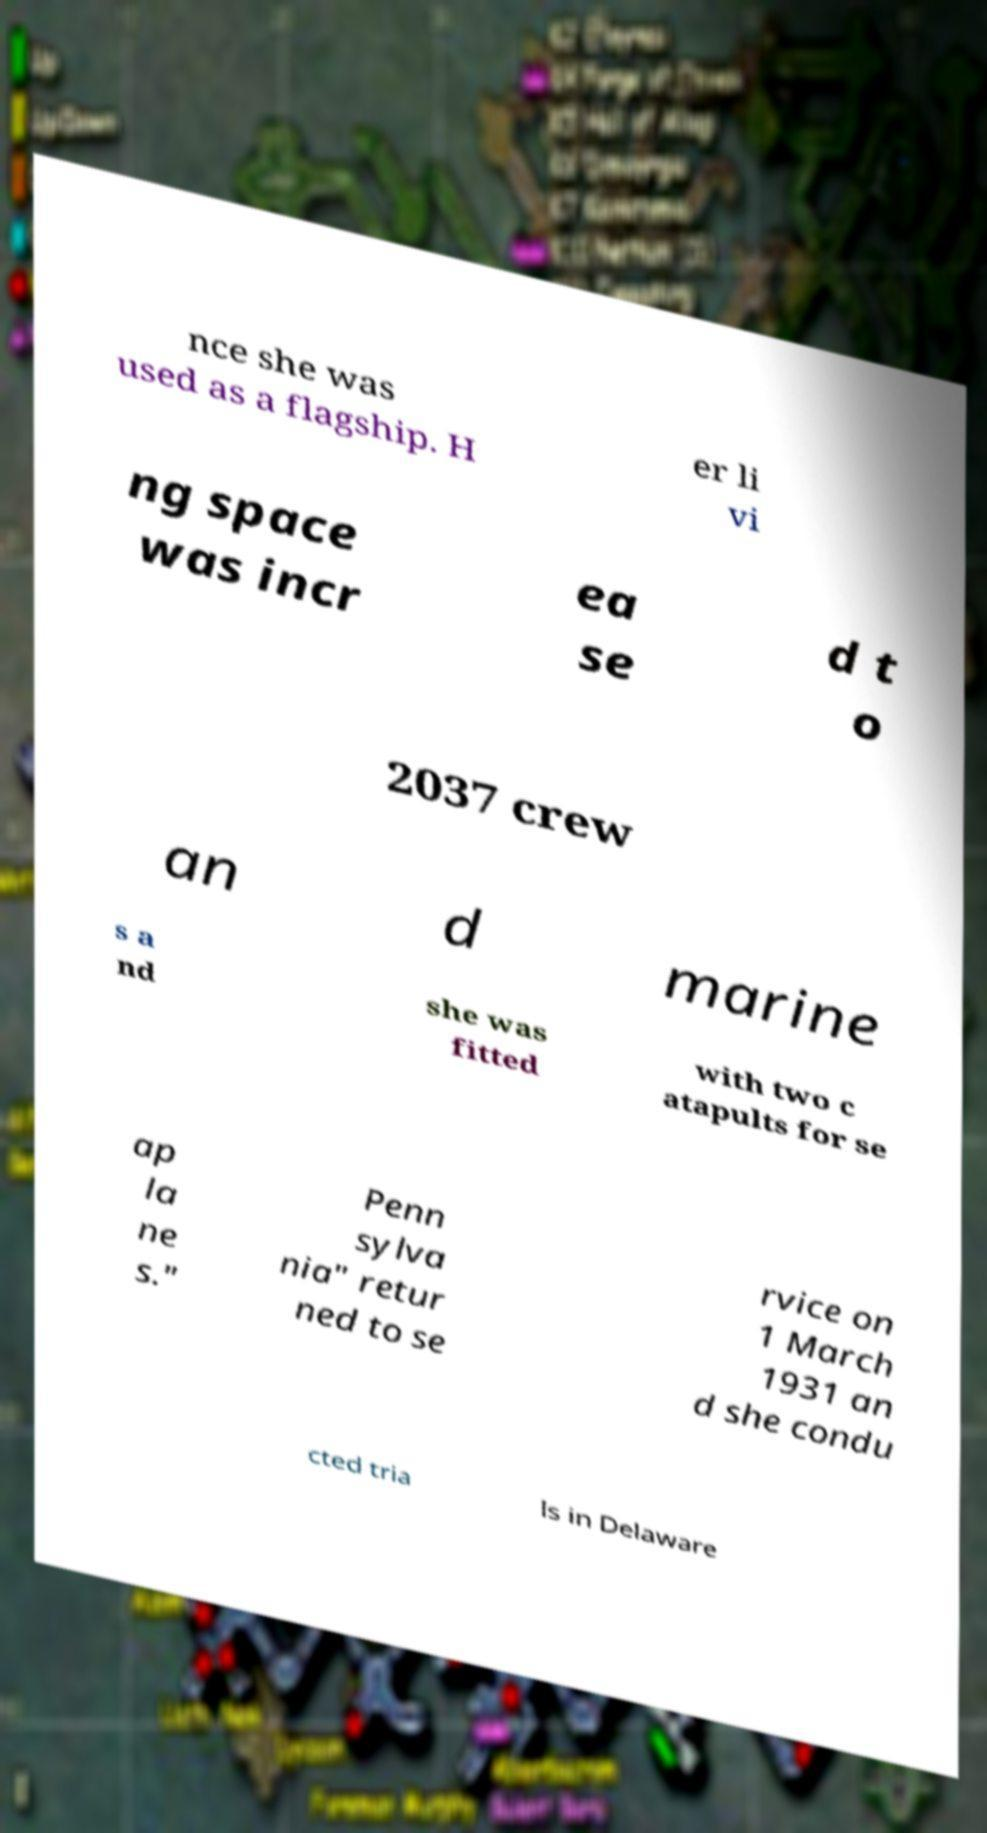Could you extract and type out the text from this image? nce she was used as a flagship. H er li vi ng space was incr ea se d t o 2037 crew an d marine s a nd she was fitted with two c atapults for se ap la ne s." Penn sylva nia" retur ned to se rvice on 1 March 1931 an d she condu cted tria ls in Delaware 